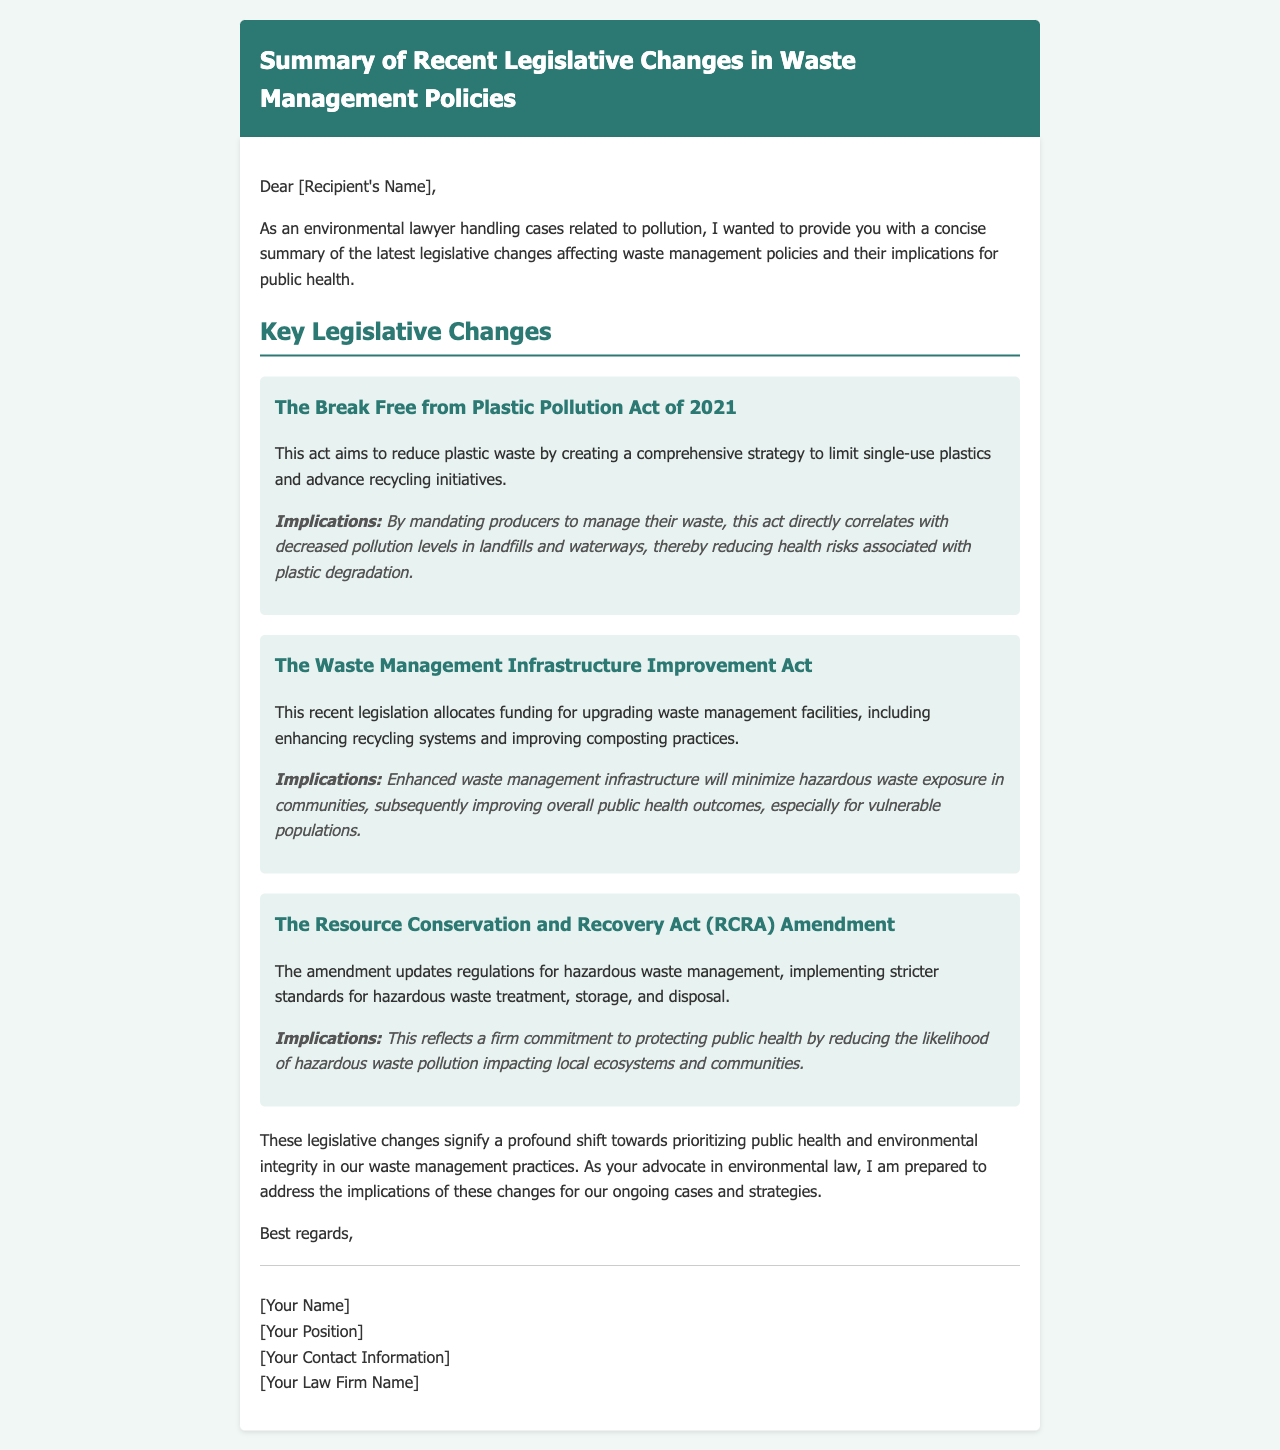What is the title of the document? The title of the document is found in the header section, which clearly states the focus of the summary.
Answer: Summary of Recent Legislative Changes in Waste Management Policies Who wrote the document? The author of the document can be found in the signature section at the end of the content.
Answer: [Your Name] What is the primary aim of The Break Free from Plastic Pollution Act of 2021? The aim of the act is described in the legislative change section, focusing on reducing plastic waste.
Answer: To reduce plastic waste What implication does The Waste Management Infrastructure Improvement Act have on public health? The implication regarding public health is clearly stated in the context of improving community health outcomes.
Answer: Improving overall public health outcomes Which act implements stricter standards for hazardous waste management? The act that updates hazardous waste management regulations is mentioned specifically in the legislative change section.
Answer: The Resource Conservation and Recovery Act (RCRA) Amendment What funding purpose does the Waste Management Infrastructure Improvement Act serve? The funding purpose is explained in the details of the act, focusing on facility upgrades.
Answer: For upgrading waste management facilities What are producers mandated to do under The Break Free from Plastic Pollution Act? The document specifies a requirement imposed on producers in terms of waste management under this act.
Answer: Manage their waste What is the implication of the RCRA Amendment for local ecosystems? The implications for local ecosystems are highlighted in terms of preventing pollution from hazardous waste.
Answer: Reducing the likelihood of hazardous waste pollution 